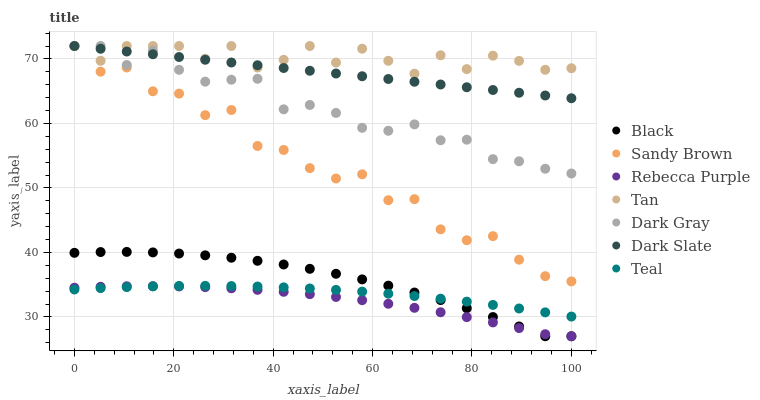Does Rebecca Purple have the minimum area under the curve?
Answer yes or no. Yes. Does Tan have the maximum area under the curve?
Answer yes or no. Yes. Does Dark Slate have the minimum area under the curve?
Answer yes or no. No. Does Dark Slate have the maximum area under the curve?
Answer yes or no. No. Is Dark Slate the smoothest?
Answer yes or no. Yes. Is Sandy Brown the roughest?
Answer yes or no. Yes. Is Black the smoothest?
Answer yes or no. No. Is Black the roughest?
Answer yes or no. No. Does Black have the lowest value?
Answer yes or no. Yes. Does Dark Slate have the lowest value?
Answer yes or no. No. Does Sandy Brown have the highest value?
Answer yes or no. Yes. Does Black have the highest value?
Answer yes or no. No. Is Black less than Dark Slate?
Answer yes or no. Yes. Is Sandy Brown greater than Teal?
Answer yes or no. Yes. Does Teal intersect Black?
Answer yes or no. Yes. Is Teal less than Black?
Answer yes or no. No. Is Teal greater than Black?
Answer yes or no. No. Does Black intersect Dark Slate?
Answer yes or no. No. 